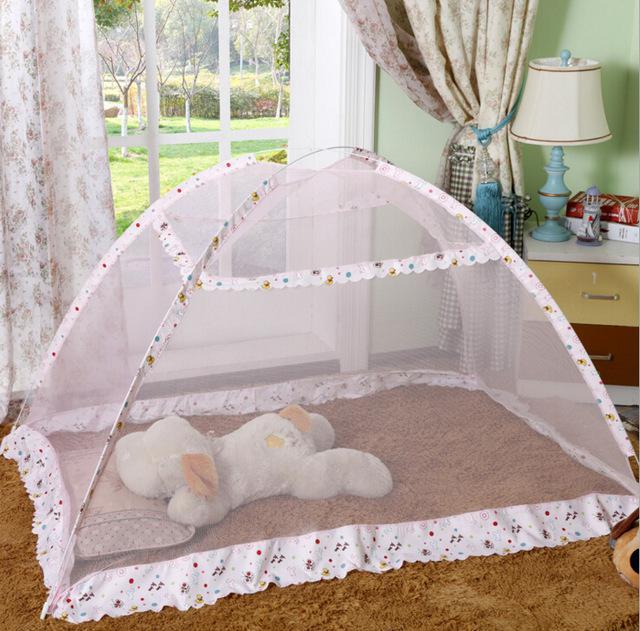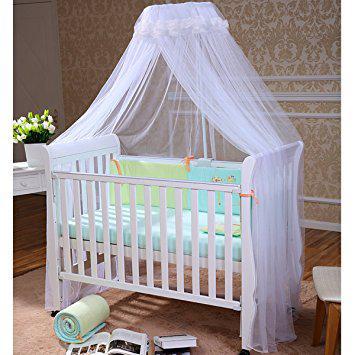The first image is the image on the left, the second image is the image on the right. For the images displayed, is the sentence "There are two pink canopies ." factually correct? Answer yes or no. No. 